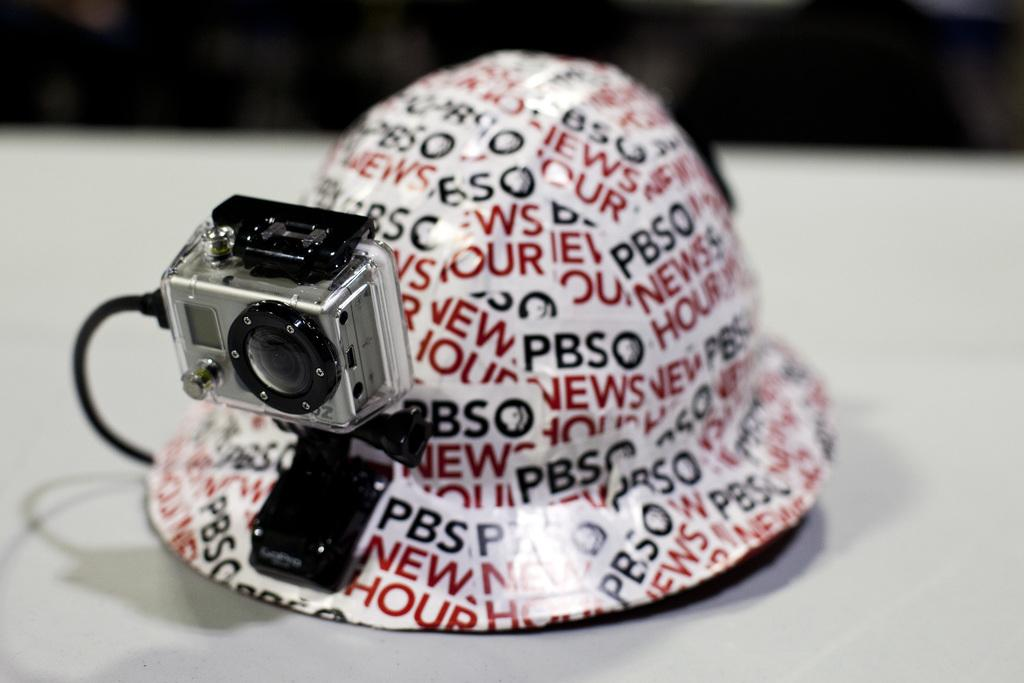What is the color of the cap in the image? The cap is white. What is written on the cap? There is writing on the cap. What other object is present in the image? There is a camera in the image. What is the color of the surface on which the cap and camera are placed? The cap and camera are on a white surface. What type of bone is visible in the image? There is no bone present in the image. What level of education is required to wear the cap in the image? The image does not provide information about the level of education required to wear the cap. 